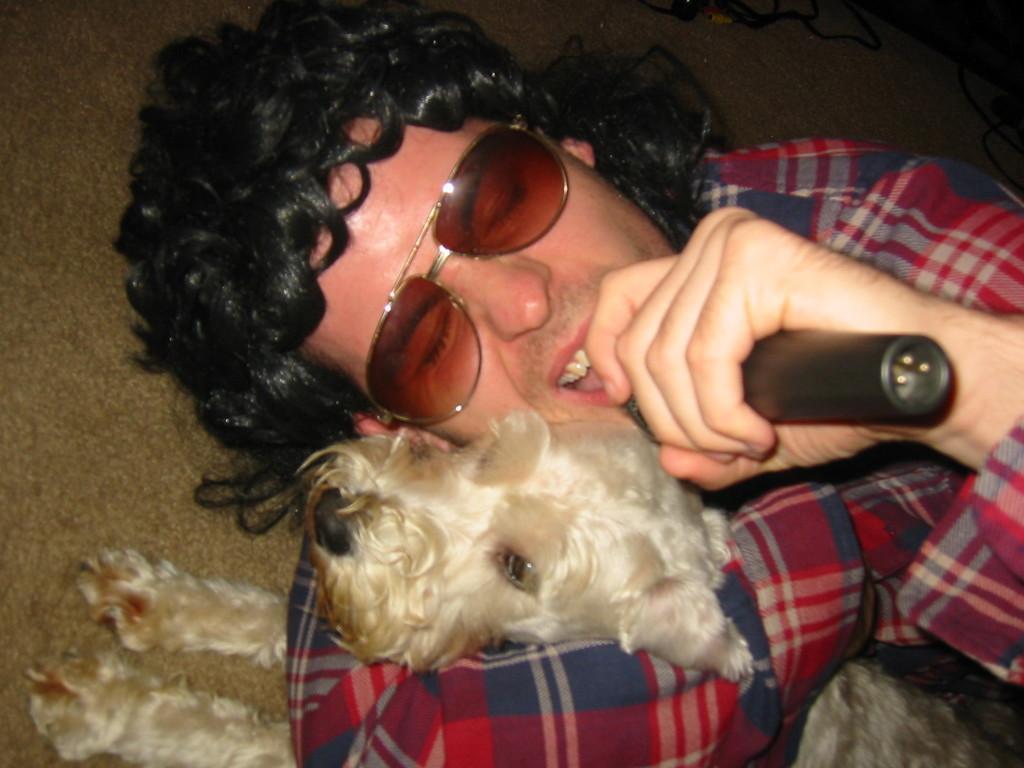Describe this image in one or two sentences. In this image there is one person is at middle of this image is wearing goggles and holding a mic and one dog, and the dog is at left side of this image which is in white color. 